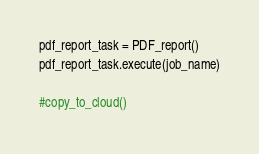Convert code to text. <code><loc_0><loc_0><loc_500><loc_500><_Python_>
pdf_report_task = PDF_report()
pdf_report_task.execute(job_name)

#copy_to_cloud()</code> 